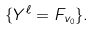<formula> <loc_0><loc_0><loc_500><loc_500>\{ Y ^ { \ell } = F _ { v _ { 0 } } \} .</formula> 